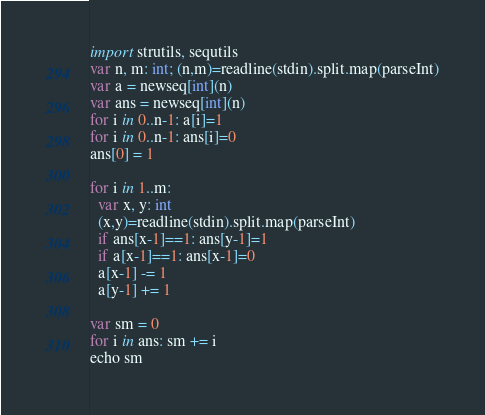<code> <loc_0><loc_0><loc_500><loc_500><_Nim_>import strutils, sequtils
var n, m: int; (n,m)=readline(stdin).split.map(parseInt)
var a = newseq[int](n)
var ans = newseq[int](n)
for i in 0..n-1: a[i]=1
for i in 0..n-1: ans[i]=0
ans[0] = 1

for i in 1..m:
  var x, y: int
  (x,y)=readline(stdin).split.map(parseInt)
  if ans[x-1]==1: ans[y-1]=1
  if a[x-1]==1: ans[x-1]=0
  a[x-1] -= 1
  a[y-1] += 1

var sm = 0
for i in ans: sm += i
echo sm</code> 